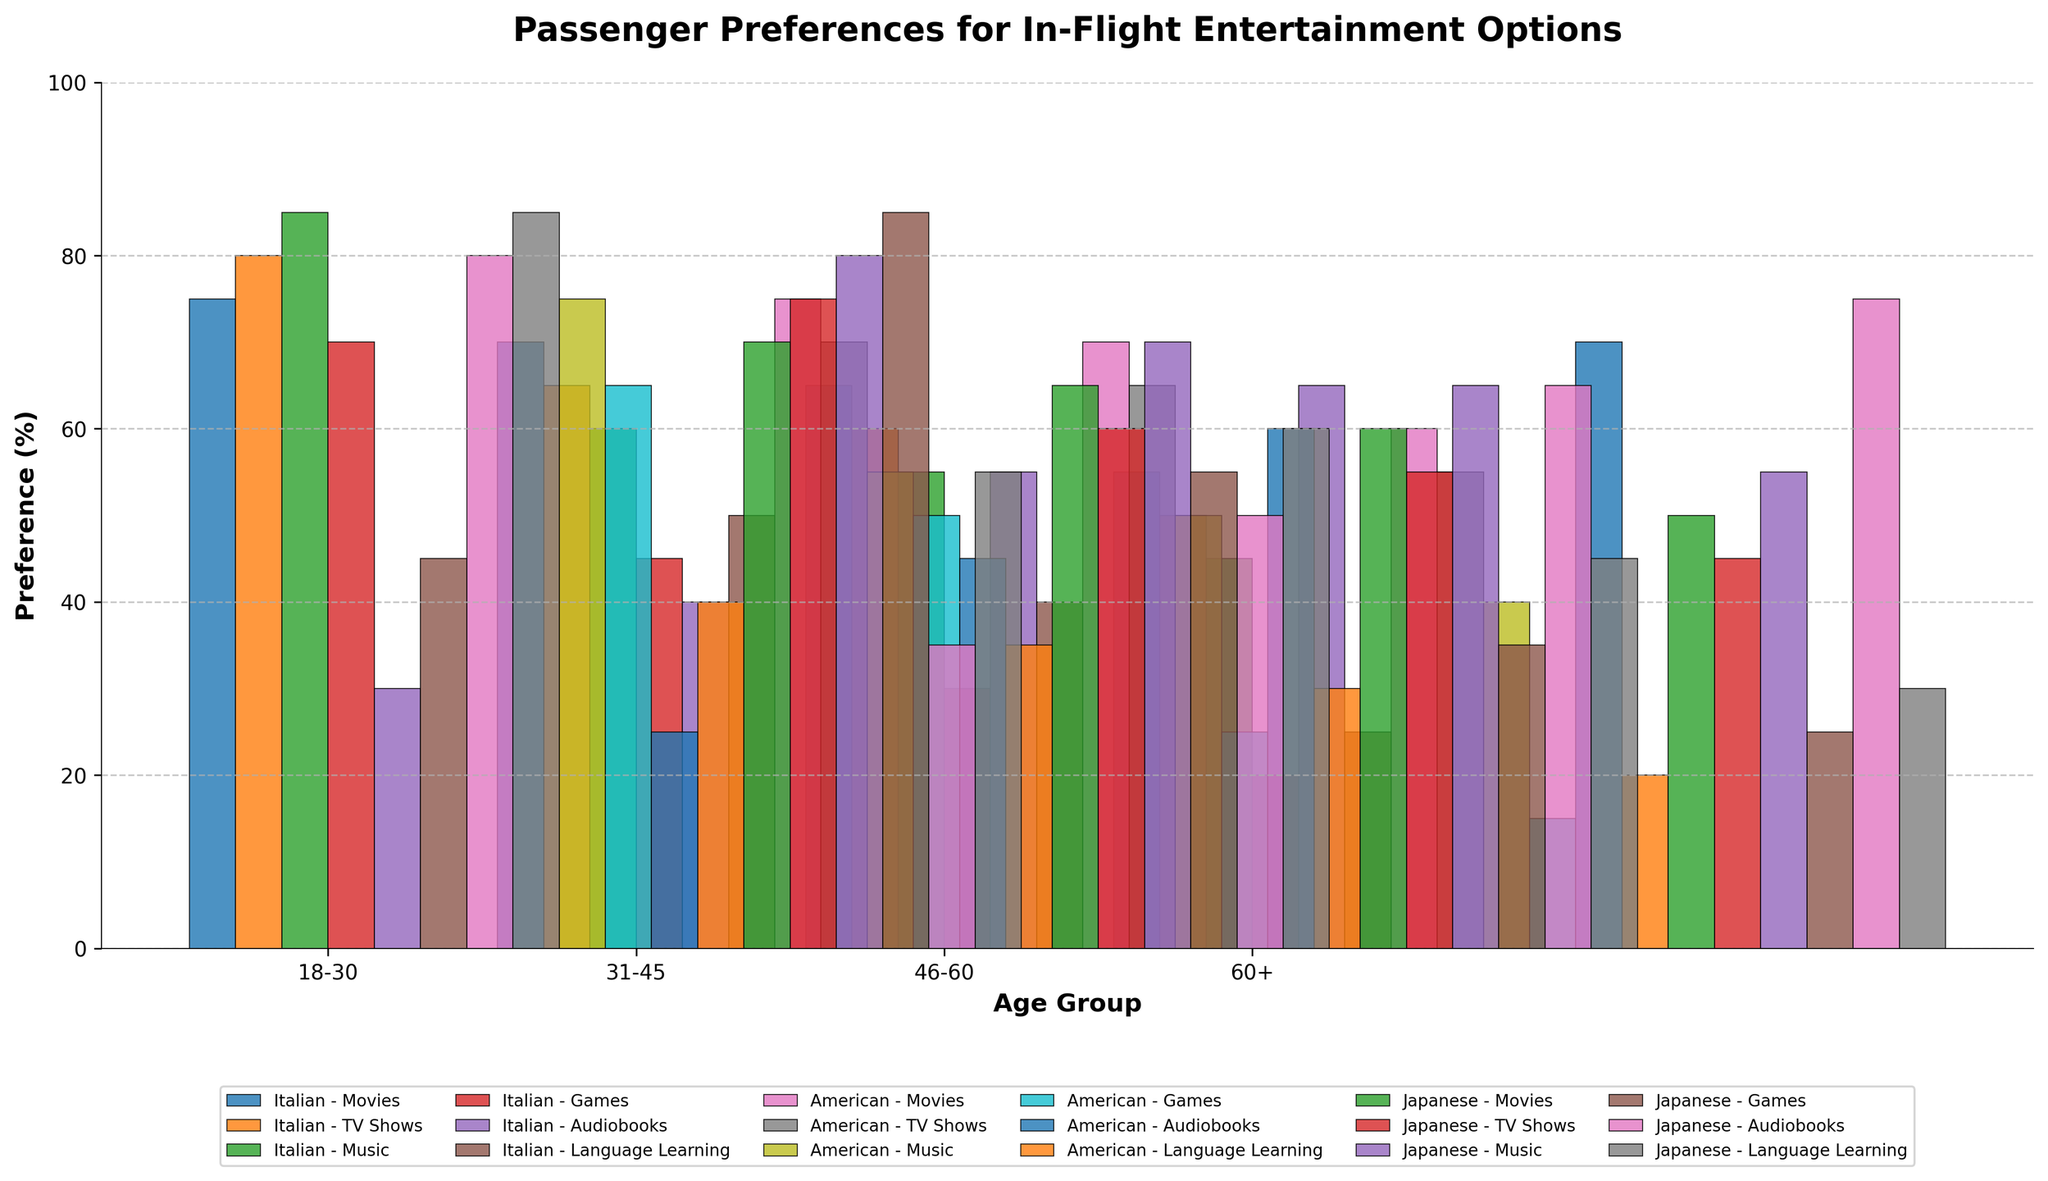What is the most preferred in-flight entertainment option for the age group 18-30? By observing the highest bars within the age group 18-30 across all nationalities, it is evident that "Music" has the highest preference percentage. For Italians, it's 85%, for Americans, it's 75%, and for Japanese, it's 80%. Hence, Music stands out as the most preferred option.
Answer: Music Compare the preference for TV shows between Americans and Japanese in the age group 46-60. Who prefers TV shows more? By comparing the bars for TV shows in the age group 46-60, Americans show a preference of 65%, while Japanese show a preference of 55%. Hence, Americans prefer TV shows more than Japanese.
Answer: Americans What is the least preferred entertainment option for Italians in the age group 60+? By observing the bars for Italians in the age group 60+, the shortest bar represents Games with a preference of 20%.
Answer: Games Which nationality and age group combination shows the highest preference for Movies? By scanning the bars for Movies across all age groups and nationalities, the tallest bar belongs to Americans in the age group 18-30 with a preference of 80%.
Answer: 18-30 Americans Calculate the average preference for Games across all age groups for Japanese passengers. We sum the preference percentages for Games for Japanese passengers across all age groups (85, 55, 35, 25) and divide by the number of age groups (4). The sum is (85 + 55 + 35 + 25) = 200, so the average is 200 / 4 = 50%.
Answer: 50% Which age group shows the highest overall preference for Language Learning, and what is the nationality? By observing the bars for Language Learning across all age groups and nationalities, the highest preference is seen in Japanese passengers within the 31-45 age group with a preference of 60%.
Answer: 31-45 Japanese Compare the preference for Audiobooks between Italians and Americans in the age group 46-60. Who prefers Audiobooks more? By comparing the bars, Italians have a preference of 55% for Audiobooks, while Americans have a preference of 60%. Therefore, Americans prefer Audiobooks more than Italians in the age group 46-60.
Answer: Americans Calculate the total preference for all entertainment options combined for the age group 31-45 and compare Italian and American passengers. Which group has a higher total preference? For Italians in age group 31-45: (70+65+60+45+40+50) = 330%. For Americans in age group 31-45: (75+70+55+50+45+35) = 330%. Both Italian and American passengers have the same total preference of 330%.
Answer: Both What is the visual difference in height between the highest and lowest preference options for Japanese passengers in the age group 60+? For Japanese passengers in age group 60+, the highest preference is for Audiobooks at 75%, and the lowest preference is Movies at 50%. The visual difference in height is thus 75% - 50% = 25%.
Answer: 25% Which nationality aged 18-30 shows a higher preference for Games and by what percentage over the lowest preference nationality in the same age group? Within the age group 18-30, Japanese show the highest preference for Games at 85%, while Americans show the lowest at 65%. The difference is 85% - 65% = 20%.
Answer: Japanese by 20% 